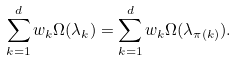<formula> <loc_0><loc_0><loc_500><loc_500>\sum _ { k = 1 } ^ { d } w _ { k } \Omega ( \lambda _ { k } ) = \sum _ { k = 1 } ^ { d } w _ { k } \Omega ( \lambda _ { \pi ( k ) } ) .</formula> 